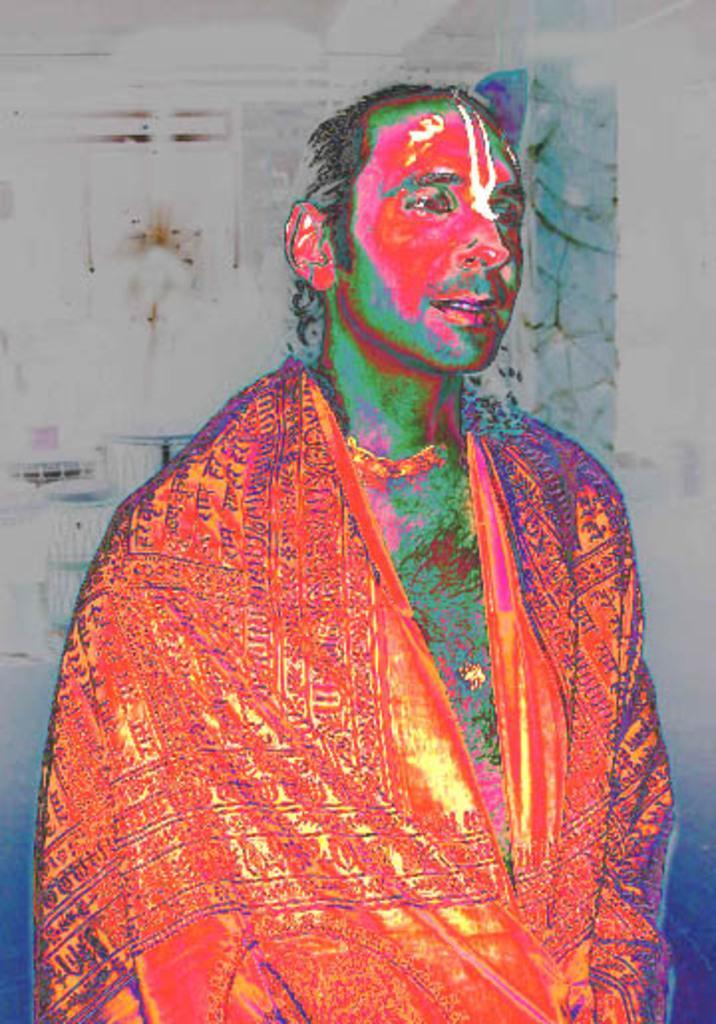Can you describe this image briefly? In this image I can see the edited picture of the person and the person is wearing orange color dress. In the background I can see few objects. 